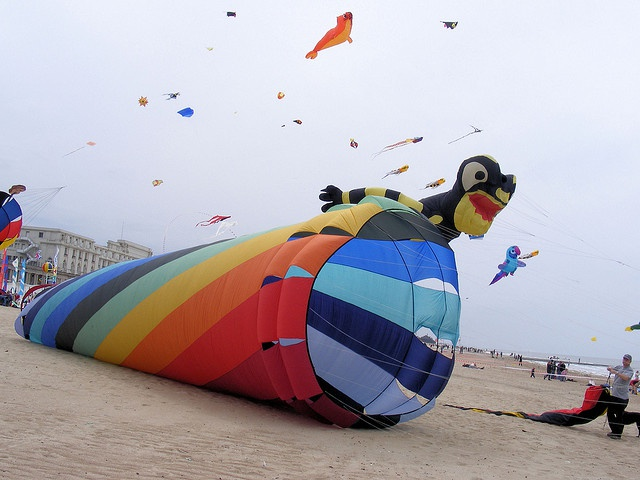Describe the objects in this image and their specific colors. I can see kite in lavender, brown, black, teal, and navy tones, kite in lavender, black, olive, and gray tones, kite in lavender, gray, darkgray, and lightgray tones, people in lavender, black, gray, and darkgray tones, and kite in lavender, blue, and gray tones in this image. 